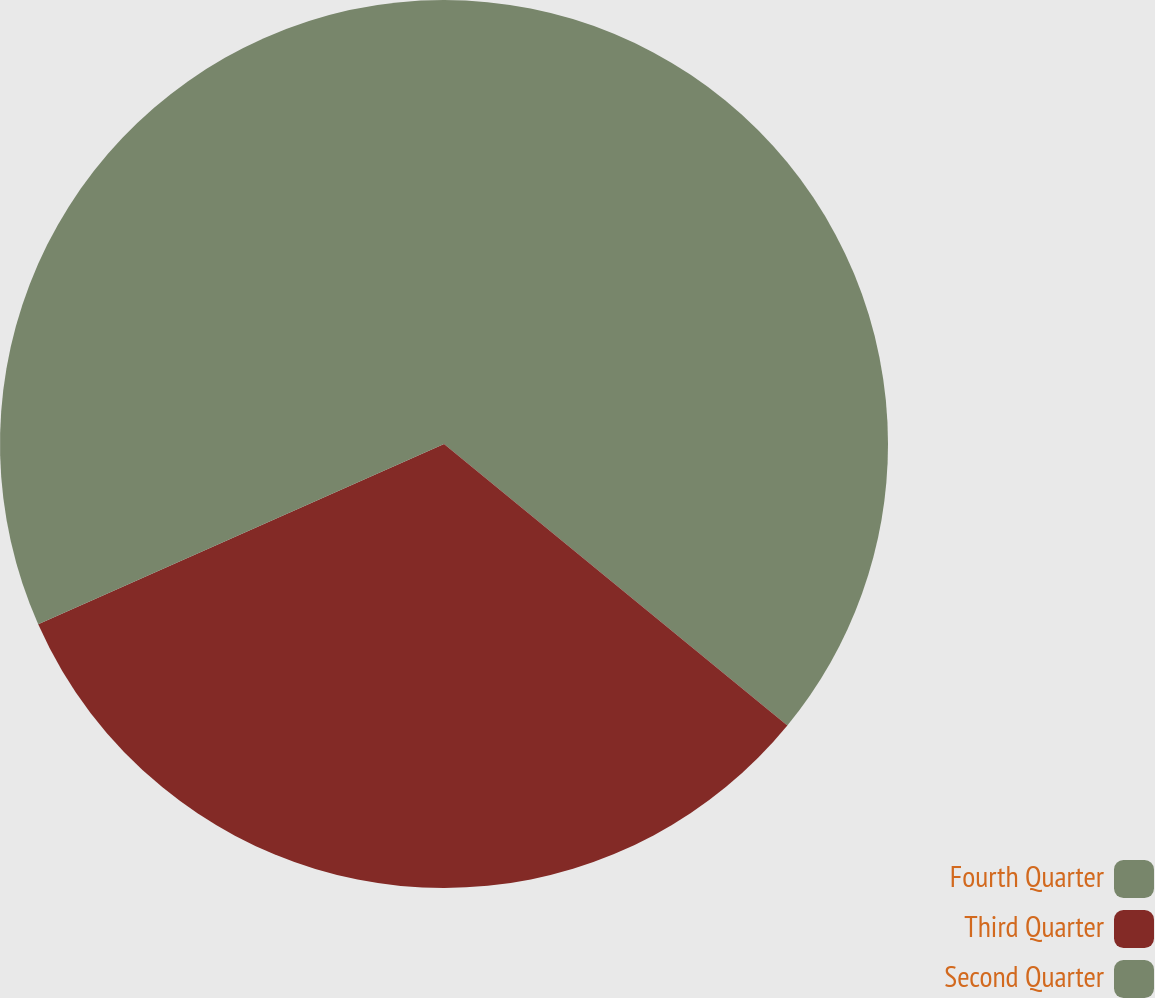Convert chart to OTSL. <chart><loc_0><loc_0><loc_500><loc_500><pie_chart><fcel>Fourth Quarter<fcel>Third Quarter<fcel>Second Quarter<nl><fcel>35.93%<fcel>32.42%<fcel>31.65%<nl></chart> 